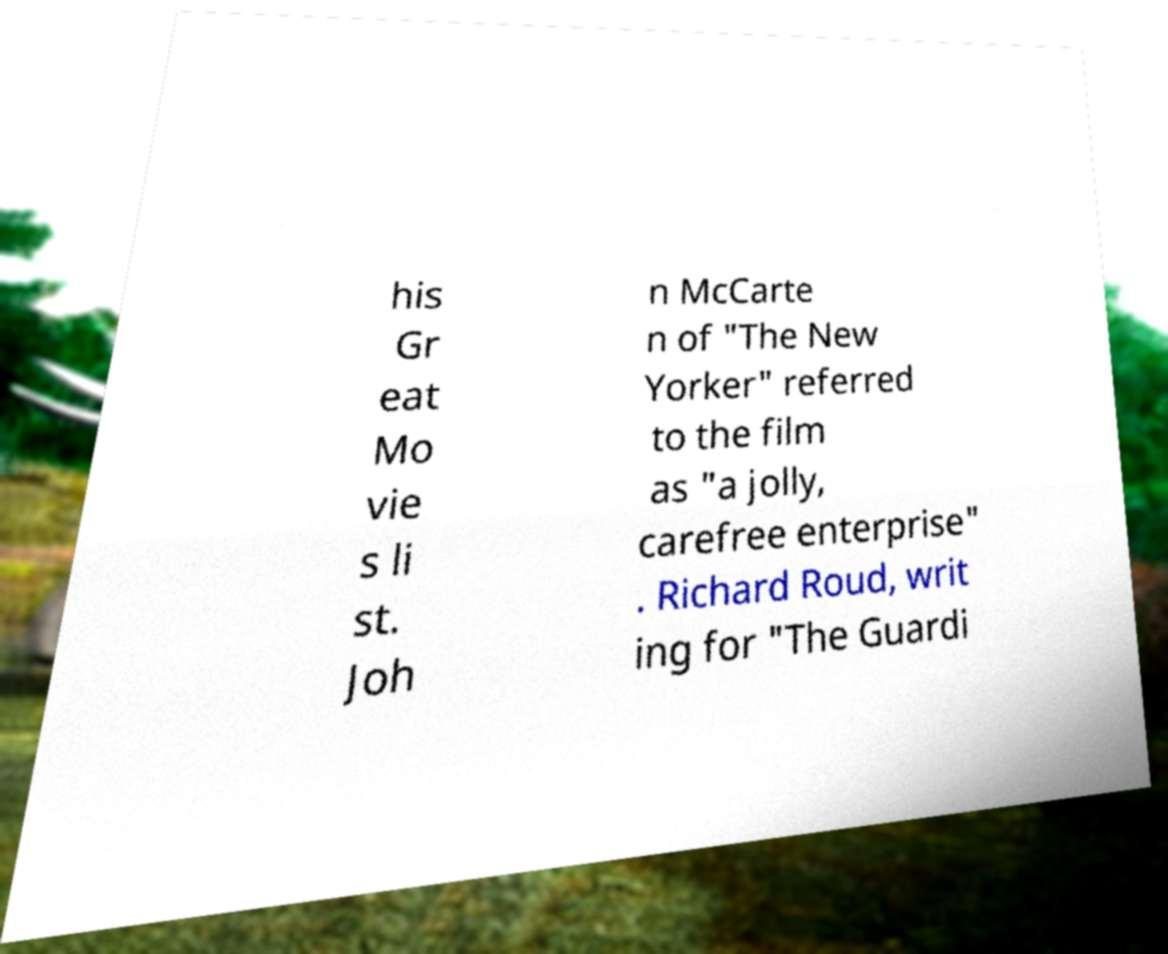Could you extract and type out the text from this image? his Gr eat Mo vie s li st. Joh n McCarte n of "The New Yorker" referred to the film as "a jolly, carefree enterprise" . Richard Roud, writ ing for "The Guardi 